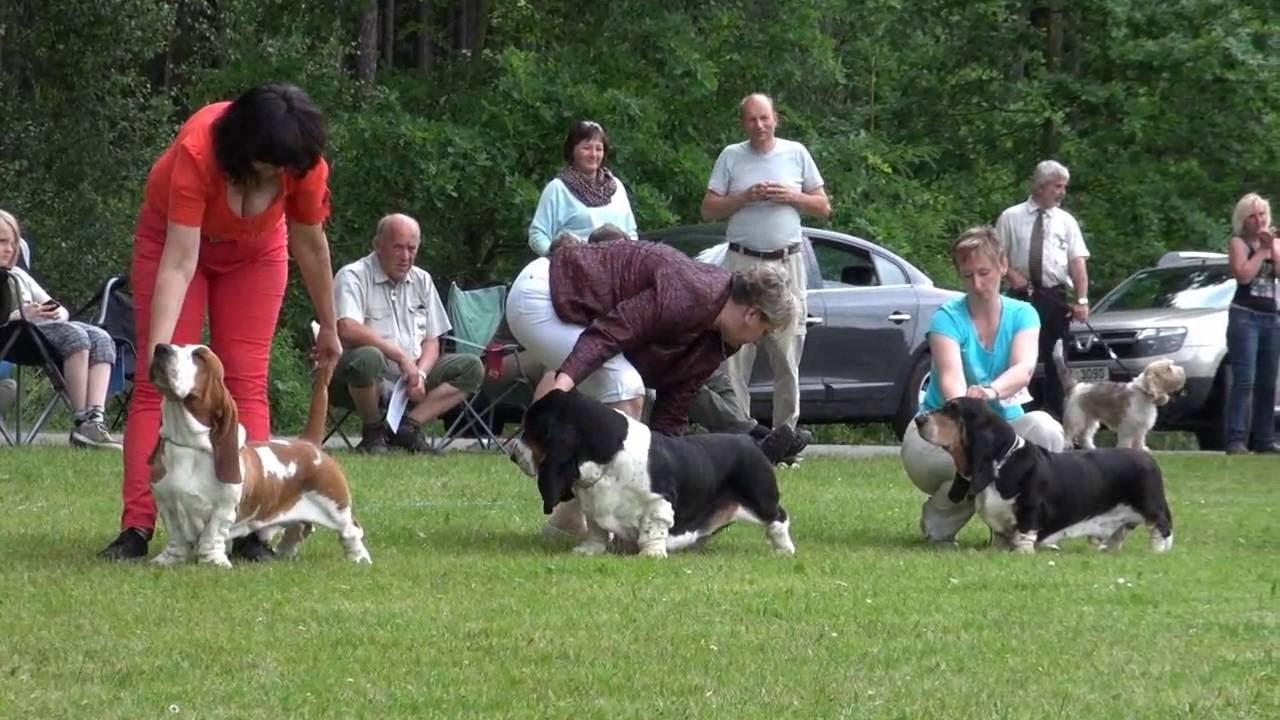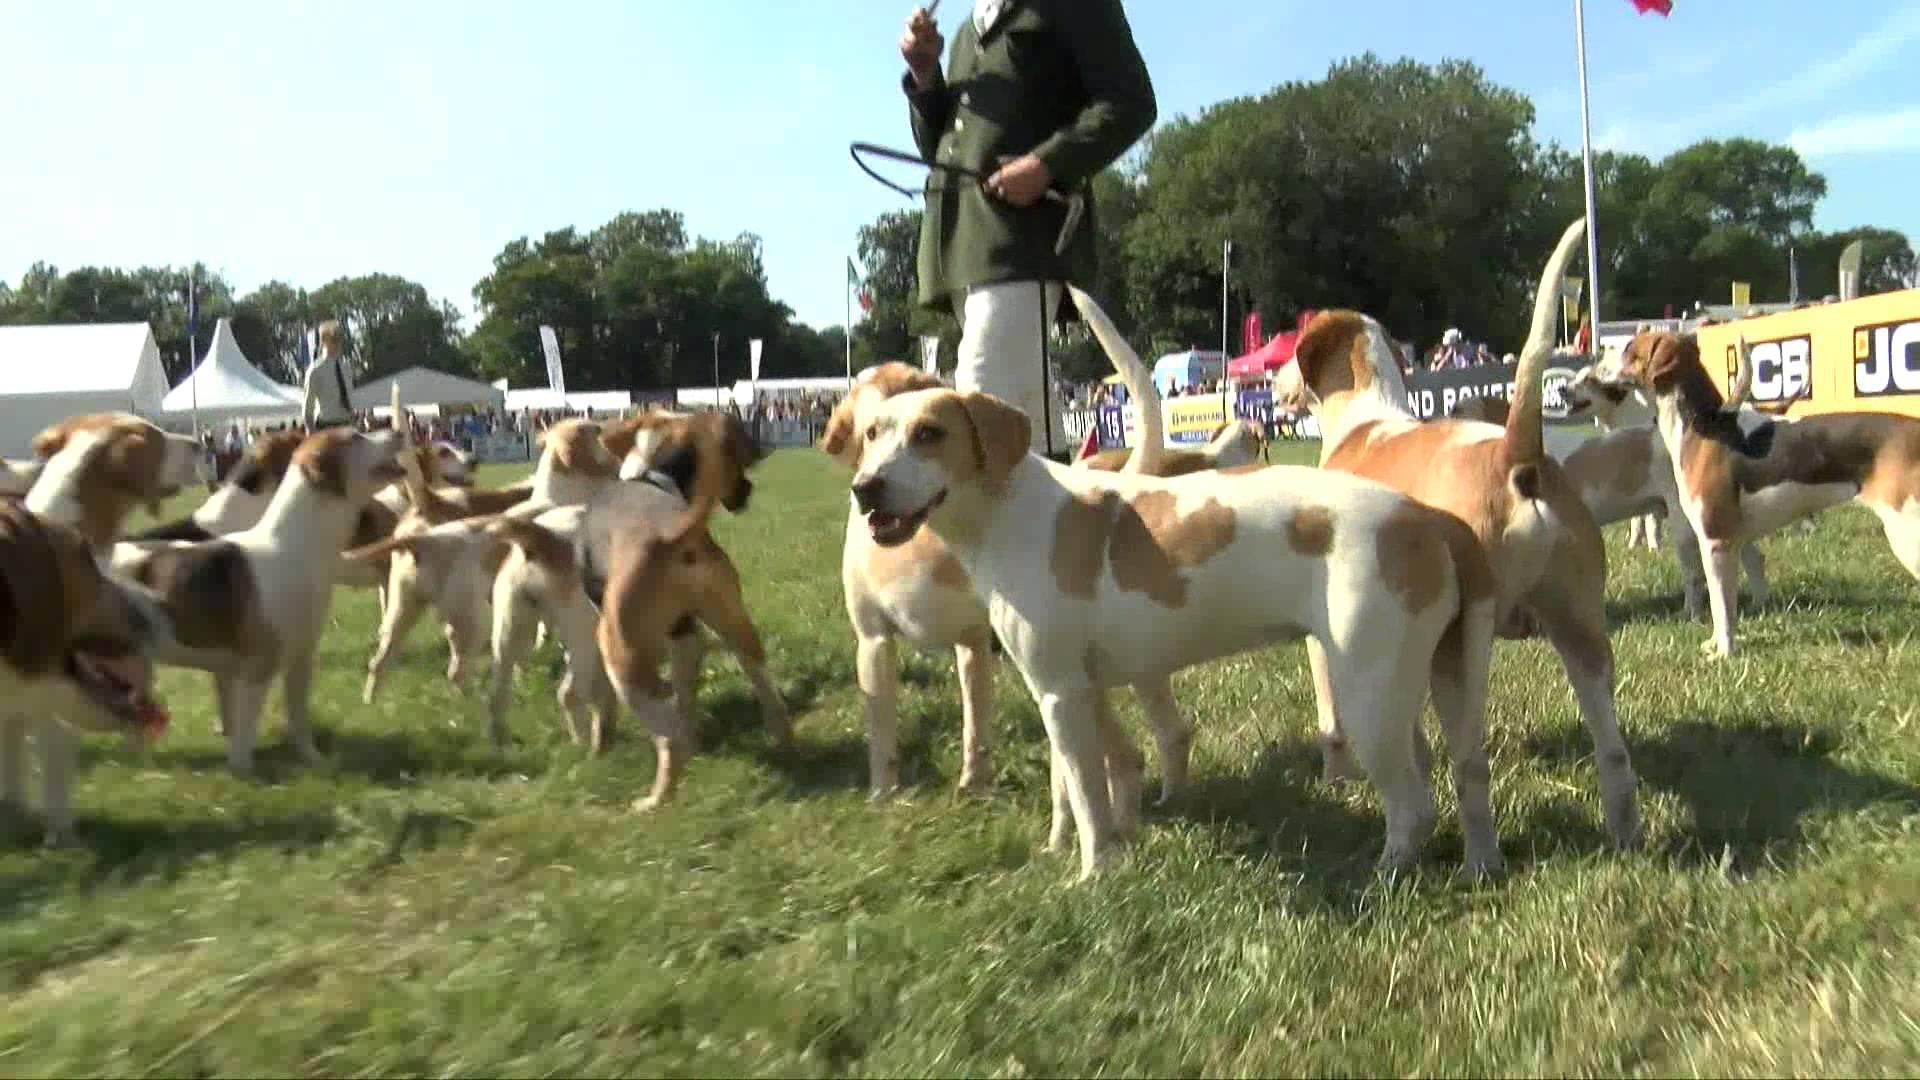The first image is the image on the left, the second image is the image on the right. Assess this claim about the two images: "A person in white pants and a dark green jacket is standing near hounds and holding a whip in one of the images.". Correct or not? Answer yes or no. Yes. The first image is the image on the left, the second image is the image on the right. Given the left and right images, does the statement "Each image shows exactly two species of mammal." hold true? Answer yes or no. Yes. 